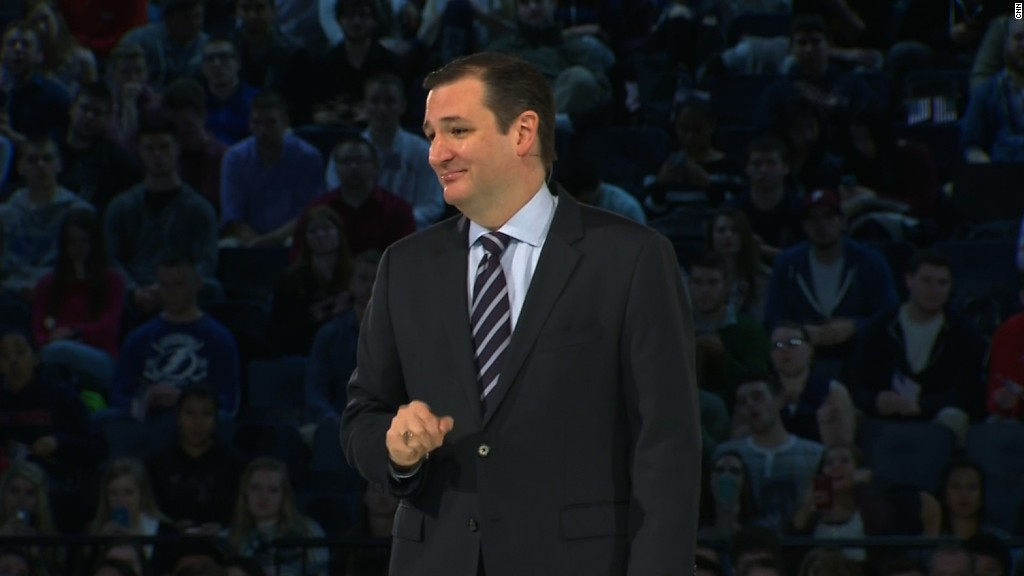If the event depicted here were a scene from a dramatic movie, what plot twists could be associated with it? If this event were a scene from a dramatic movie, several plot twists could add intrigue:
1. The speaker reveals a shocking secret that changes the course of the storyline, perhaps about a character's true identity or a hidden agenda.
2. A member of the audience stands up and accuses the speaker of a serious crime, leading to a tense confrontation.
3. The lights suddenly go out, and chaos ensues as a mysterious figure appears on stage with an important message.
4. The speaker is not who they appear to be but an impostor or undercover agent working for a covert organization.
5. The presentation includes a startling revelation about future events or technological advancements that deeply affect the characters' lives. 